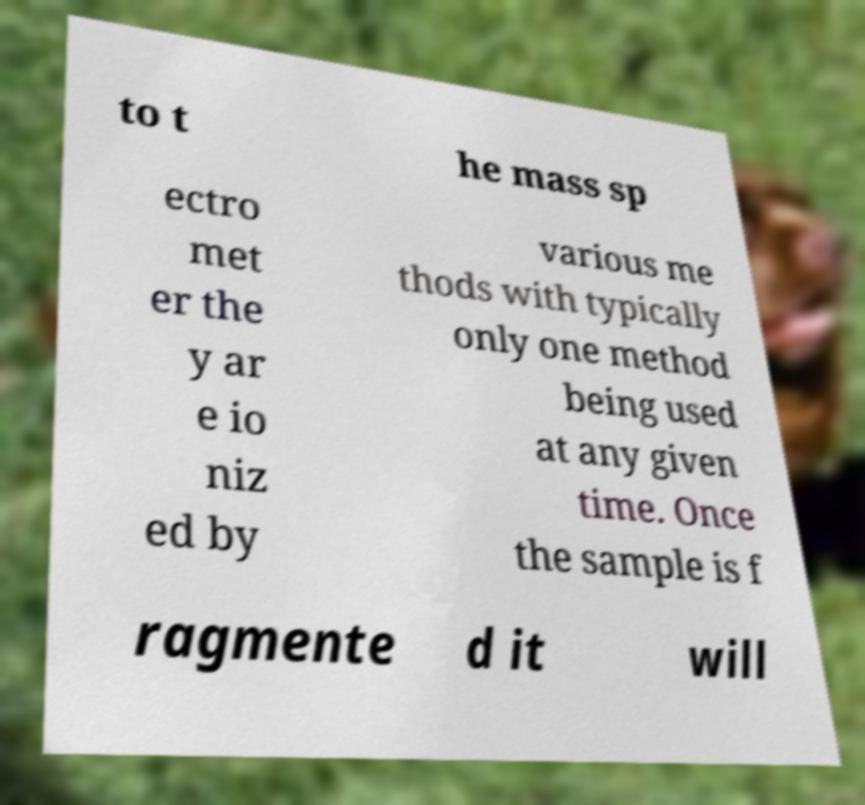Please identify and transcribe the text found in this image. to t he mass sp ectro met er the y ar e io niz ed by various me thods with typically only one method being used at any given time. Once the sample is f ragmente d it will 